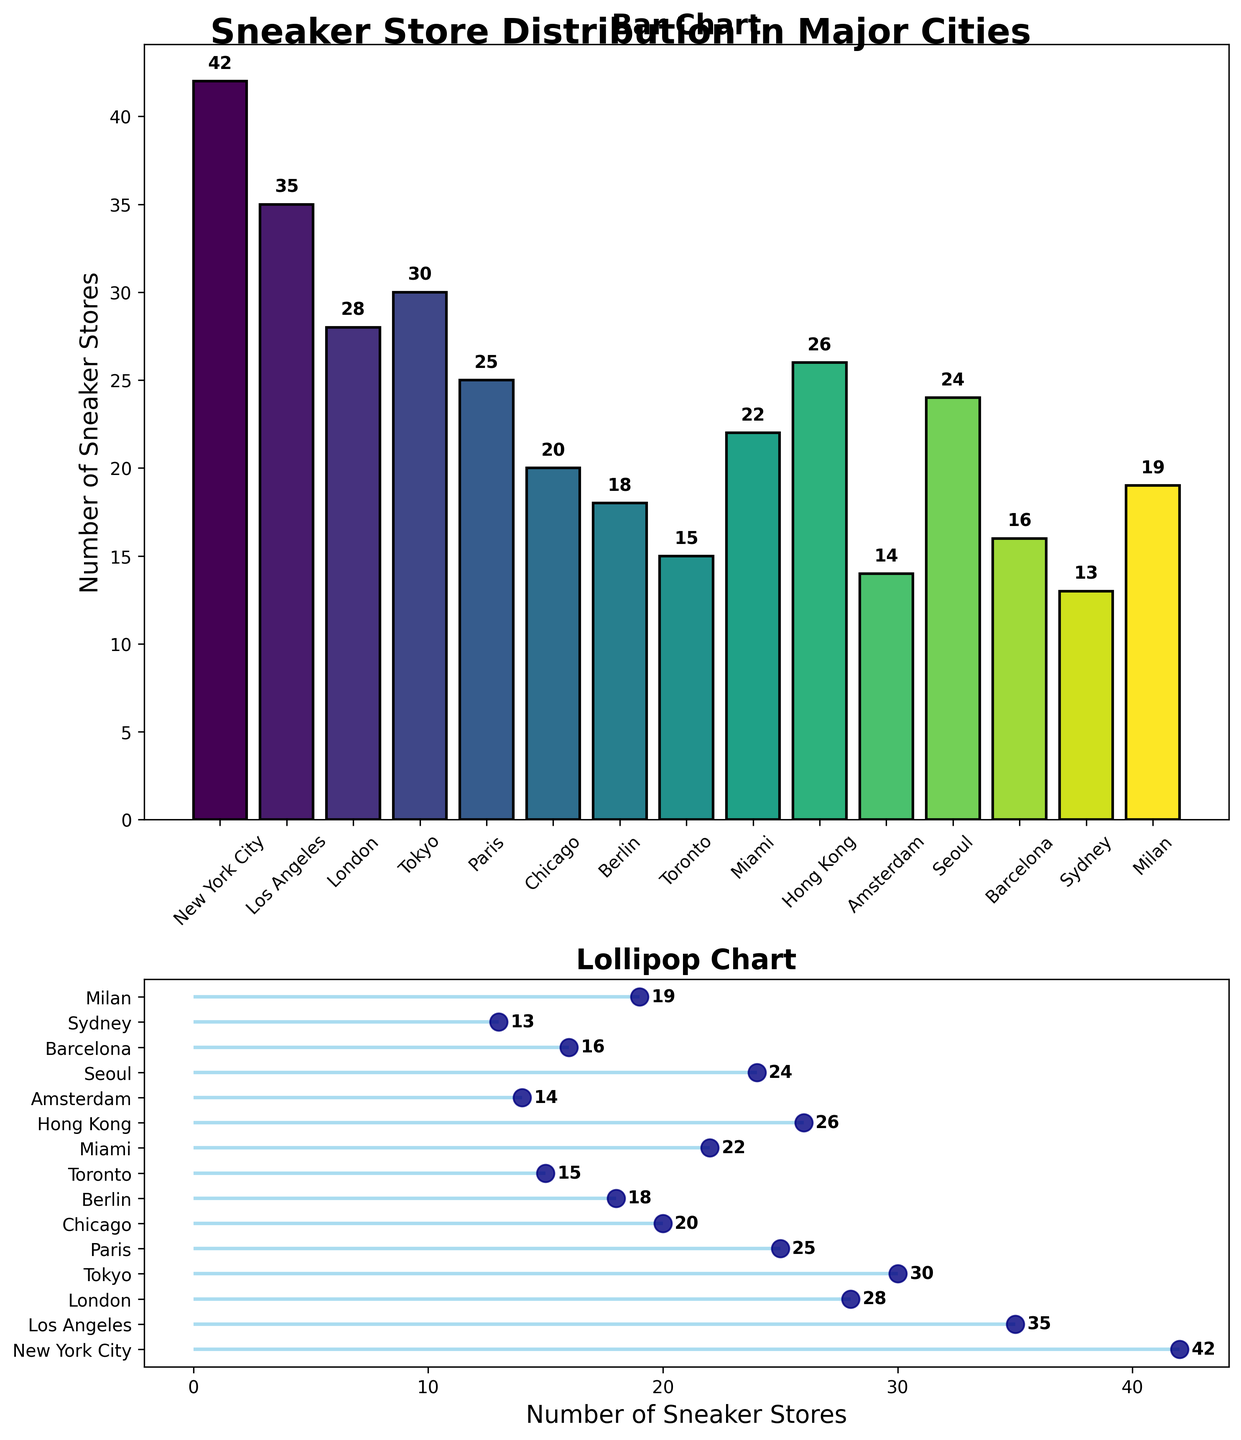what's the city with the most sneaker stores? The bar chart in the figure shows the number of sneaker stores for each city. By comparing the height of the bars, the tallest bar indicates the city with the most sneaker stores. The tallest bar corresponds to New York City.
Answer: New York City how many sneaker stores are there in Sydney? Locate the bar representing Sydney in the bar chart. The text above the bar indicates the count of sneaker stores, which is 13.
Answer: 13 what is the total number of sneaker stores in Chicago and Miami? Chicago and Miami have 20 and 22 sneaker stores, respectively. Summing these values gives the total: 20 + 22 = 42.
Answer: 42 which two cities have an equal number of sneaker stores? Identify bars or points with matching values. Seoul and Paris both have 24 sneaker stores, as indicated by the bars and labels.
Answer: Seoul and Paris what's the average number of sneaker stores across all cities? Add the number of sneaker stores for all cities and divide by the number of cities. Sum = 42 + 35 + 28 + 30 + 25 + 20 + 18 + 15 + 22 + 26 + 14 + 24 + 16 + 13 + 19 = 347; average = 347 / 15 ≈ 23.13.
Answer: 23.13 which city has fewer sneaker stores, Amsterdam or Berlin? Compare the number of sneaker stores for Amsterdam (14) and Berlin (18). Amsterdam has fewer stores.
Answer: Amsterdam how many more stores does London have compared to Toronto? Determine the difference between the number of stores in London (28) and Toronto (15): 28 - 15 = 13.
Answer: 13 what’s the median number of sneaker stores among the cities listed? Arrange the number of stores in ascending order: 13, 14, 15, 16, 18, 19, 20, 22, 24, 25, 26, 28, 30, 35, 42. The median is the 8th value in this list, which is 22.
Answer: 22 which city has the closest number of sneaker stores to the average? The average number of stores is 23.13. Compare each city's store count to find the closest: Sydney (13), Amsterdam (14), Toronto (15), Barcelona (16), Berlin (18), Milan (19), Chicago (20), Miami (22), Seoul (24), Paris (25), Hong Kong (26), London (28), Tokyo (30), Los Angeles (35), New York City (42). The closest is Miami with 22.
Answer: Miami what's the difference in the number of sneaker stores between the city with the most and the city with the least sneaker stores? The city with the most stores is New York City (42) and the least is Sydney (13). The difference is: 42 - 13 = 29.
Answer: 29 